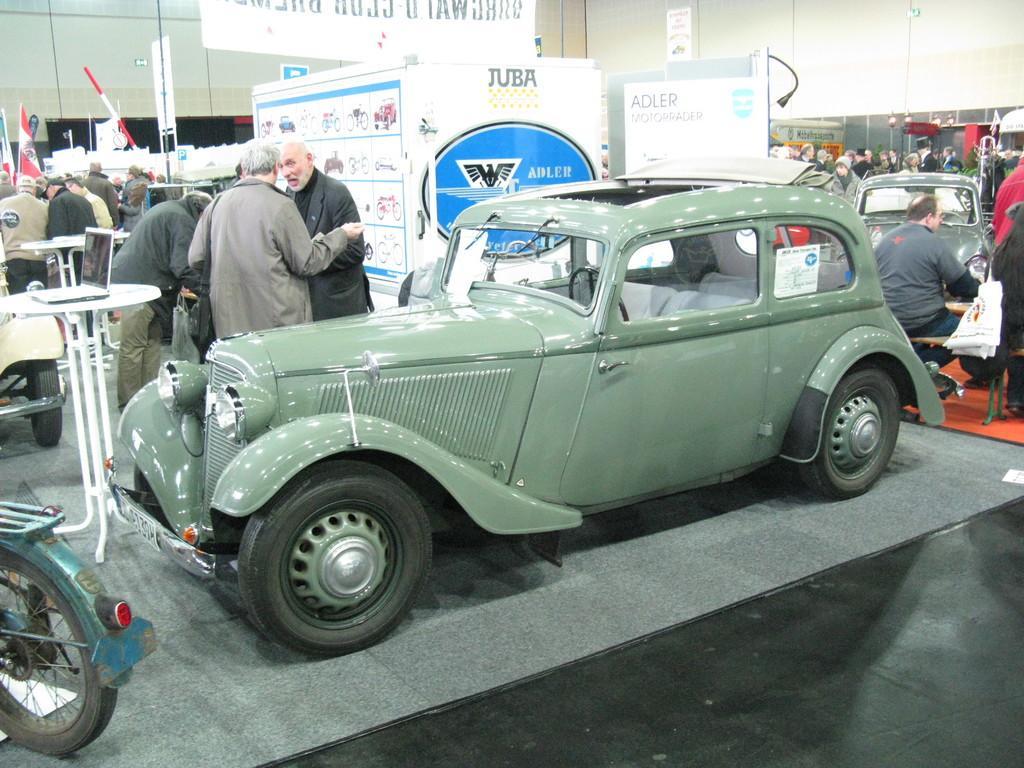In one or two sentences, can you explain what this image depicts? In the middle it is a car and in the left side 2 women are standing and talking each other. 